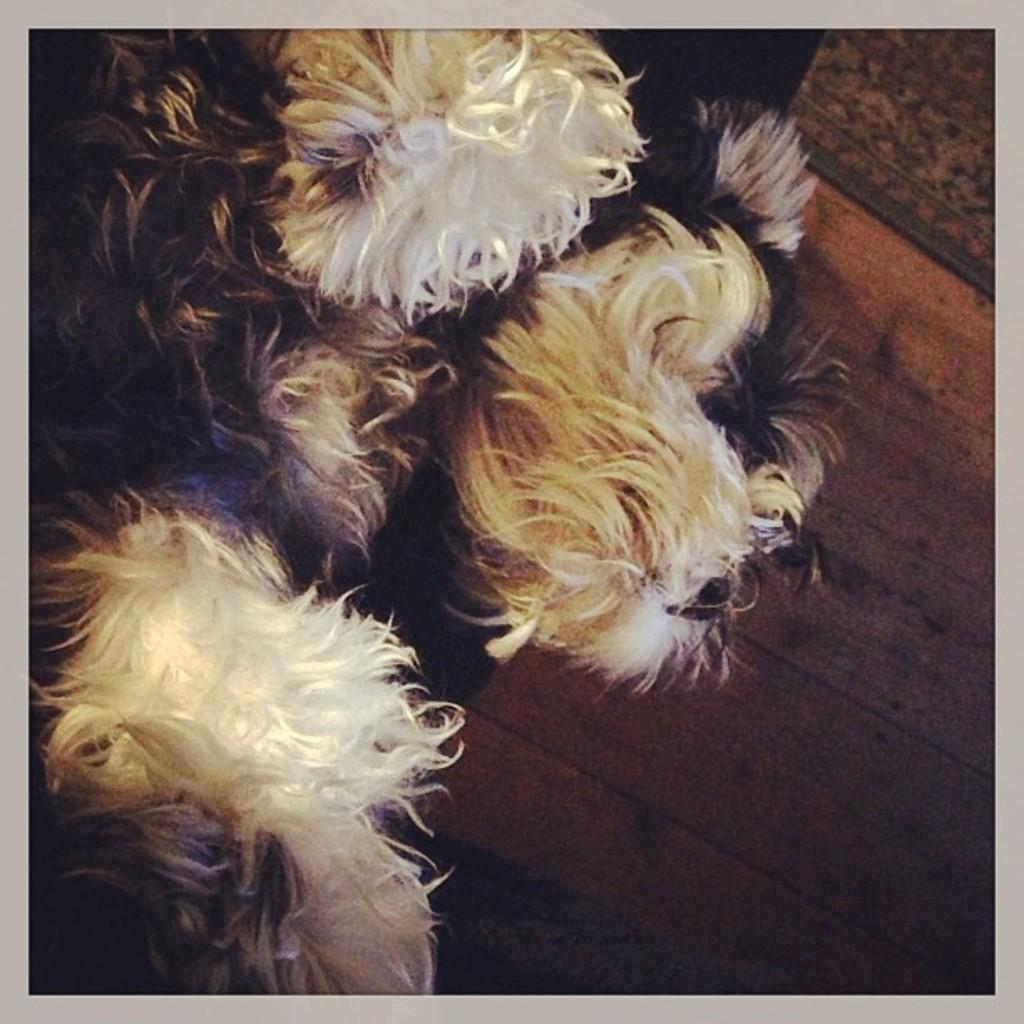What animal can be seen in the image? There is a dog in the image. What type of surface is the dog standing on? The dog is on a wooden floor. How many fingers does the dog have in the image? Dogs do not have fingers; they have paws with claws. In the image, the dog has paws, not fingers. 